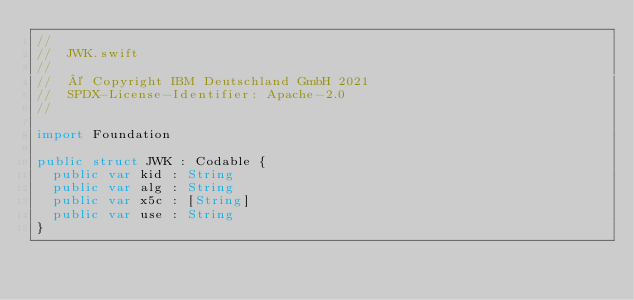Convert code to text. <code><loc_0><loc_0><loc_500><loc_500><_Swift_>//
//  JWK.swift
//
//  © Copyright IBM Deutschland GmbH 2021
//  SPDX-License-Identifier: Apache-2.0
//

import Foundation

public struct JWK : Codable {
  public var kid : String
  public var alg : String
  public var x5c : [String]
  public var use : String
}
</code> 